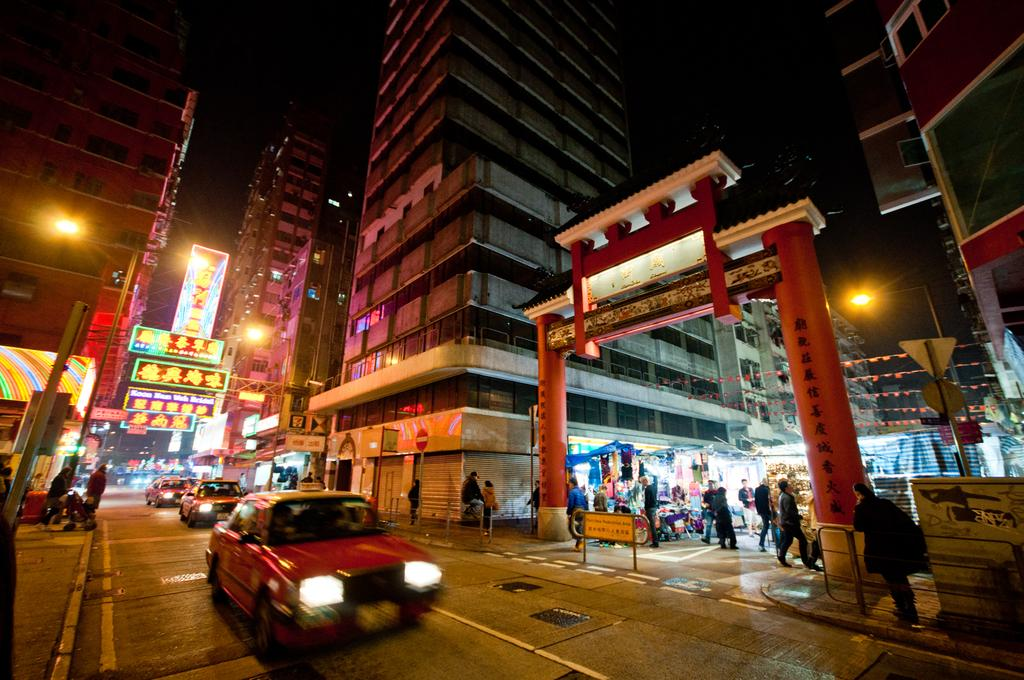What type of structures can be seen in the image? There are buildings in the image. What architectural feature is present in the image? There is an arch in the image. Are there any people visible in the image? Yes, there are persons in the image. What mode of transportation can be seen in the image? There are cars in the image. What type of pathway is present in the image? There is a road in the image. What type of signage is present in the image? There are name boards, sign boards, and street lights in the image. What part of the natural environment is visible in the image? The sky is visible in the image. What type of wine is being served at the partner's stomach in the image? There is no mention of wine, a partner, or a stomach in the image. 